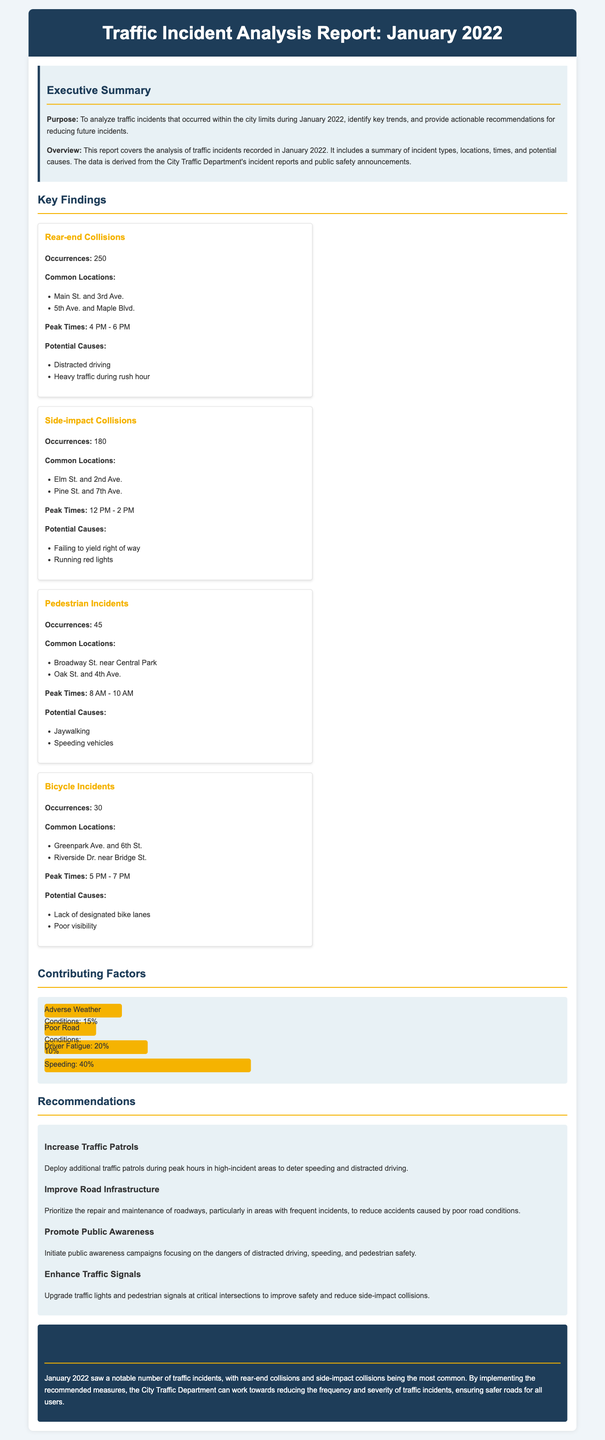What is the total number of rear-end collisions? The document states that there were 250 occurrences of rear-end collisions reported in January 2022.
Answer: 250 What are the common locations for side-impact collisions? The document lists Elm St. and 2nd Ave. and Pine St. and 7th Ave. as common locations for side-impact collisions.
Answer: Elm St. and 2nd Ave., Pine St. and 7th Ave What is the peak time for pedestrian incidents? According to the report, the peak time for pedestrian incidents is from 8 AM to 10 AM.
Answer: 8 AM - 10 AM What percentage of incidents were attributed to speeding? The document indicates that 40% of incidents were due to speeding, which is the highest contributing factor.
Answer: 40% Which type of incident had the fewest occurrences? The report identifies bicycle incidents with only 30 occurrences as having the fewest incidents.
Answer: 30 What is the main recommendation regarding traffic patrols? The document recommends increasing traffic patrols during peak hours in high-incident areas.
Answer: Increase Traffic Patrols How many total occurrences of pedestrian incidents were reported? The document states that there were 45 pedestrian incidents reported in January 2022.
Answer: 45 What was the purpose of this report? The report's purpose is to analyze traffic incidents that occurred within the city limits during January 2022.
Answer: Analyze traffic incidents What does the report suggest to improve road infrastructure? The report recommends prioritizing repair and maintenance of roadways to reduce accidents caused by poor road conditions.
Answer: Improve Road Infrastructure 